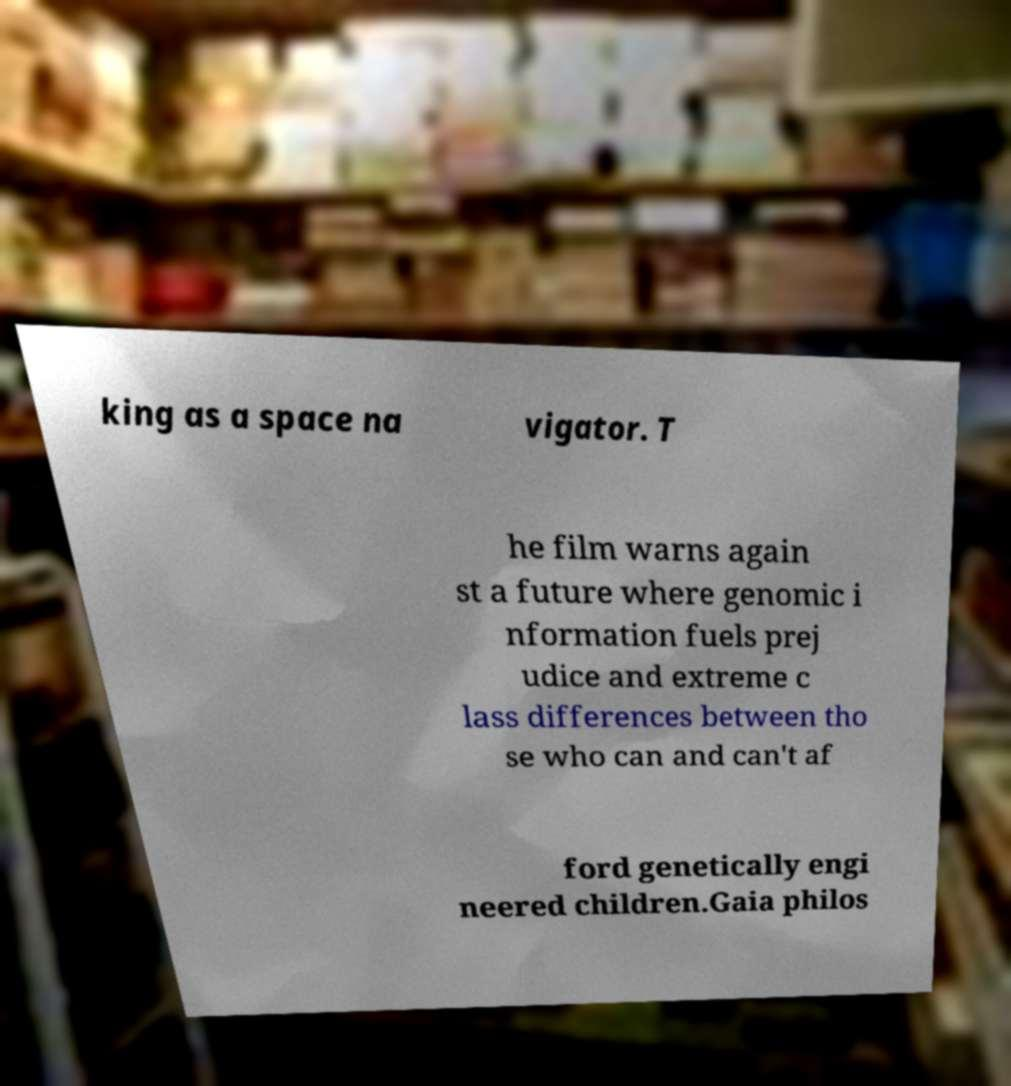What messages or text are displayed in this image? I need them in a readable, typed format. king as a space na vigator. T he film warns again st a future where genomic i nformation fuels prej udice and extreme c lass differences between tho se who can and can't af ford genetically engi neered children.Gaia philos 